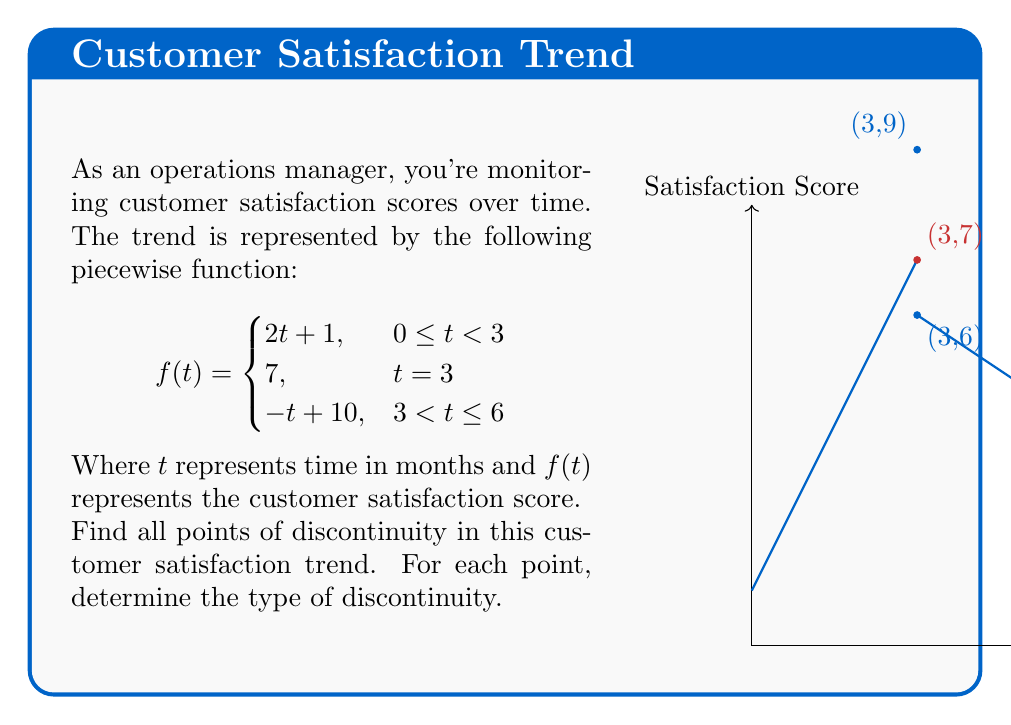Can you solve this math problem? To find points of discontinuity, we need to examine the function at each piece and at the transition points:

1) For $0 \leq t < 3$: $f(t) = 2t + 1$
   This is continuous for all points in this interval.

2) For $3 < t \leq 6$: $f(t) = -t + 10$
   This is continuous for all points in this interval.

3) At $t = 3$: We need to check left limit, right limit, and function value:

   Left limit: $\lim_{t \to 3^-} f(t) = \lim_{t \to 3^-} (2t + 1) = 2(3) + 1 = 7$
   
   Right limit: $\lim_{t \to 3^+} f(t) = \lim_{t \to 3^+} (-t + 10) = -3 + 10 = 7$
   
   Function value: $f(3) = 7$

   The left limit, right limit, and function value are all equal to 7.

4) However, there's a jump in the function definition at $t = 3$:
   
   $\lim_{t \to 3^-} f(t) = 7$
   $\lim_{t \to 3^+} f(t) = 7$
   $f(3) = 7$

   Although all these values are equal, the function is defined differently for $t < 3$, $t = 3$, and $t > 3$. This creates a point of discontinuity.

The point $t = 3$ is a point of discontinuity. Specifically, it's a removable discontinuity (also known as a point discontinuity), because the limit exists and equals the function value, but the function is defined differently at this point compared to its surroundings.
Answer: Removable discontinuity at $t = 3$ 